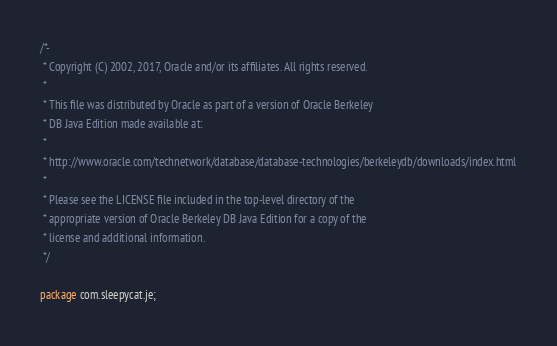Convert code to text. <code><loc_0><loc_0><loc_500><loc_500><_Java_>/*-
 * Copyright (C) 2002, 2017, Oracle and/or its affiliates. All rights reserved.
 *
 * This file was distributed by Oracle as part of a version of Oracle Berkeley
 * DB Java Edition made available at:
 *
 * http://www.oracle.com/technetwork/database/database-technologies/berkeleydb/downloads/index.html
 *
 * Please see the LICENSE file included in the top-level directory of the
 * appropriate version of Oracle Berkeley DB Java Edition for a copy of the
 * license and additional information.
 */

package com.sleepycat.je;
</code> 